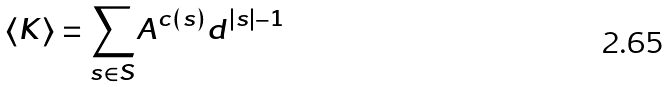<formula> <loc_0><loc_0><loc_500><loc_500>\langle K \rangle = \underset { s \in S } { \sum } A ^ { c ( s ) } d ^ { | s | - 1 }</formula> 